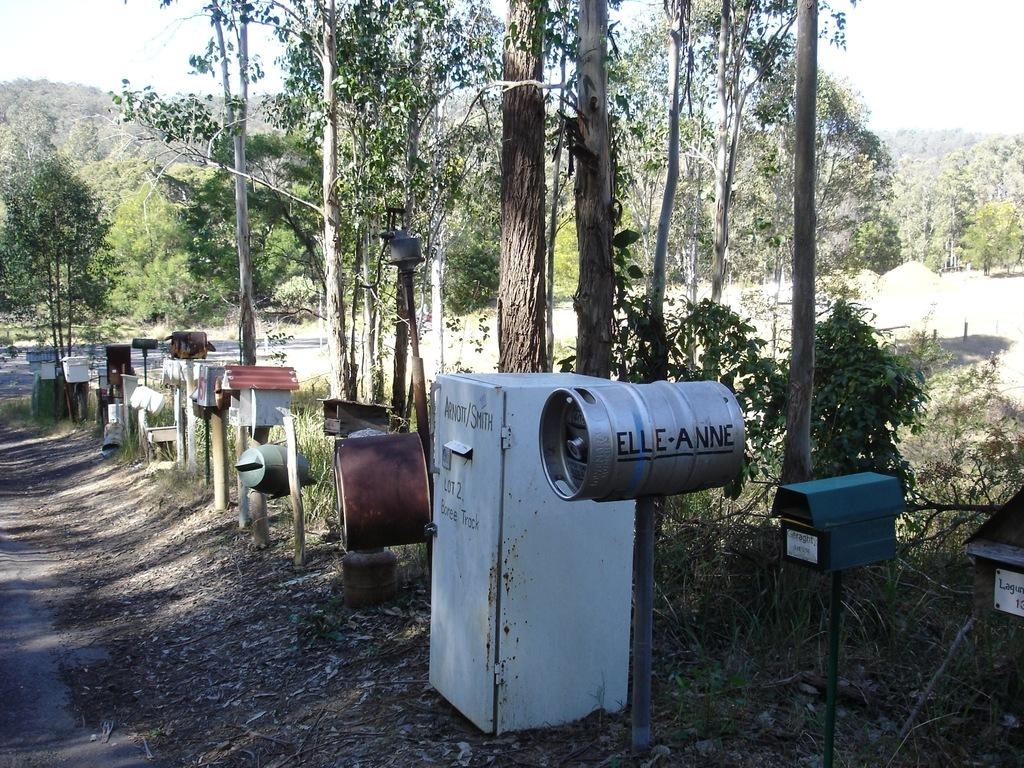What objects are placed on the ground in the image? There are furnaces placed on the ground in the image. What else can be seen on the ground in the image? Shredded leaves are present on the ground. What type of vegetation is visible in the image? There are plants in the image. What can be seen in the background of the image? Trees and the sky are visible in the background of the image. How many minutes does the crow take to fly across the image? There is no crow present in the image, so it is not possible to determine how many minutes it would take for a crow to fly across the image. 